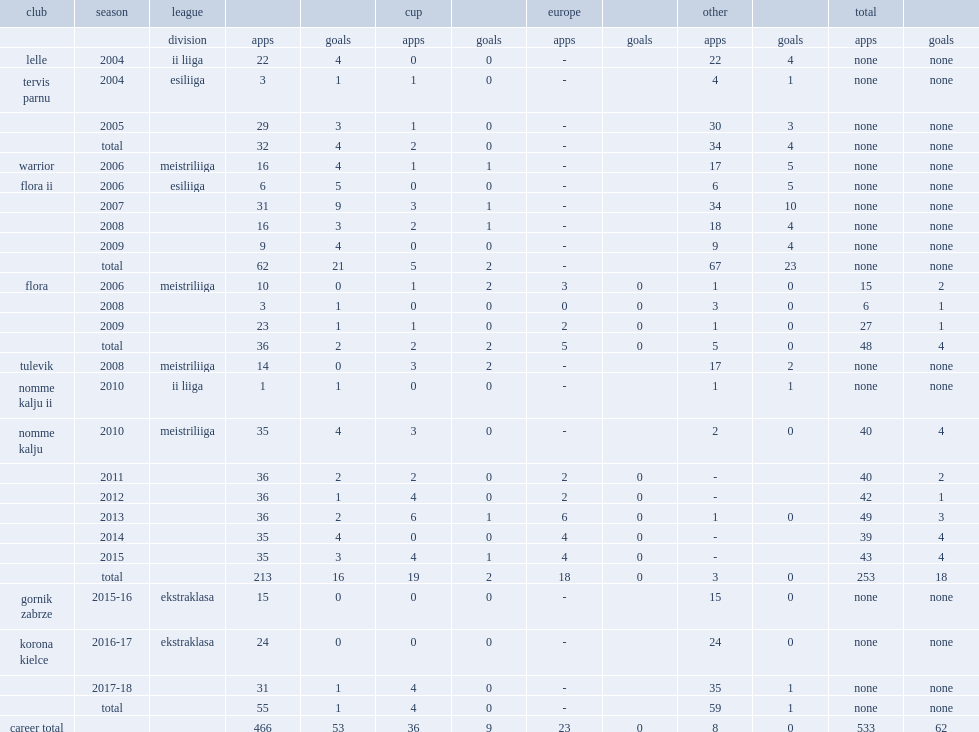Which club did ken kallaste play for in 2006? Warrior. 